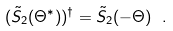Convert formula to latex. <formula><loc_0><loc_0><loc_500><loc_500>( \tilde { S } _ { 2 } ( \Theta ^ { * } ) ) ^ { \dagger } = \tilde { S } _ { 2 } ( - \Theta ) \ .</formula> 